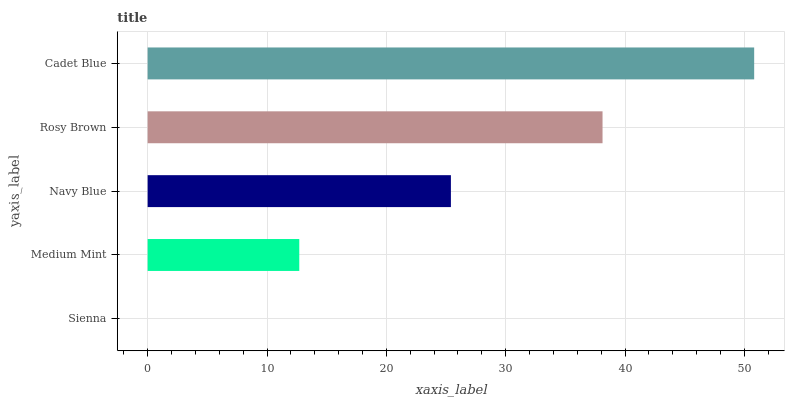Is Sienna the minimum?
Answer yes or no. Yes. Is Cadet Blue the maximum?
Answer yes or no. Yes. Is Medium Mint the minimum?
Answer yes or no. No. Is Medium Mint the maximum?
Answer yes or no. No. Is Medium Mint greater than Sienna?
Answer yes or no. Yes. Is Sienna less than Medium Mint?
Answer yes or no. Yes. Is Sienna greater than Medium Mint?
Answer yes or no. No. Is Medium Mint less than Sienna?
Answer yes or no. No. Is Navy Blue the high median?
Answer yes or no. Yes. Is Navy Blue the low median?
Answer yes or no. Yes. Is Cadet Blue the high median?
Answer yes or no. No. Is Cadet Blue the low median?
Answer yes or no. No. 